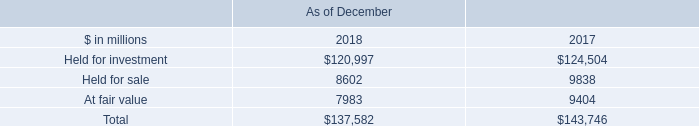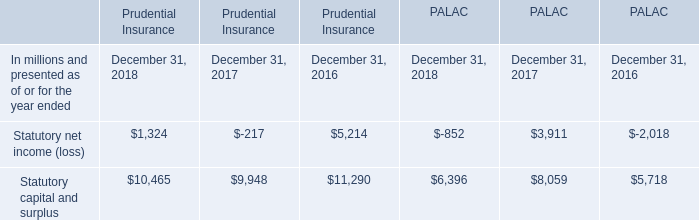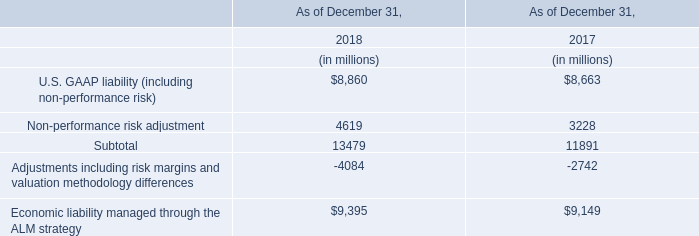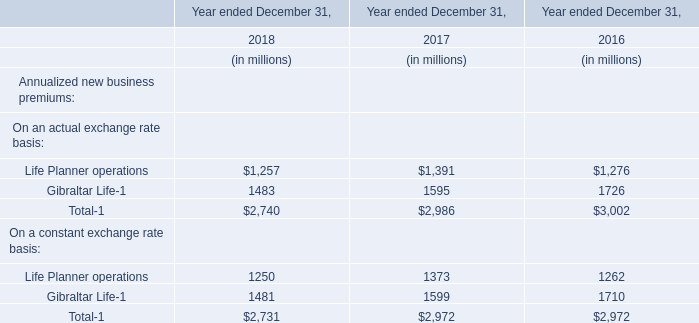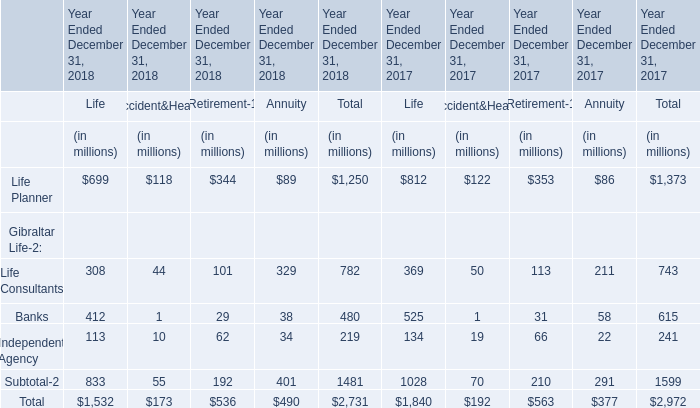What is the percentage of Life Consultants in relation to the total in 2018? 
Computations: (782 / 2731)
Answer: 0.28634. 